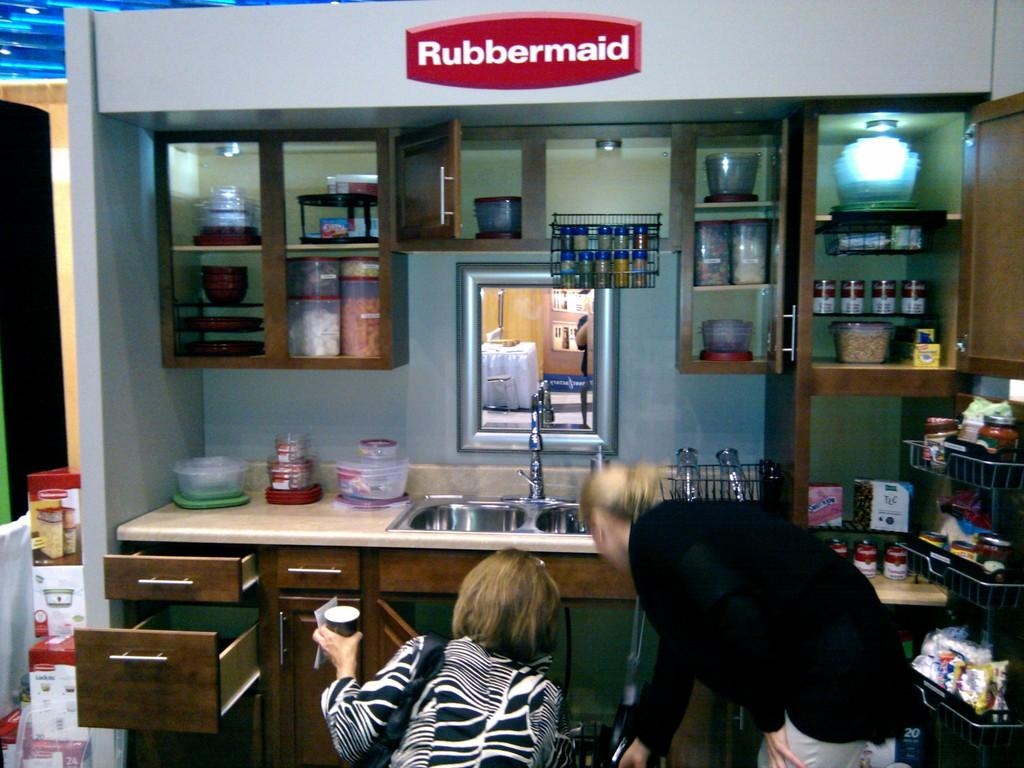<image>
Offer a succinct explanation of the picture presented. A kitchen display is sponsored by the company Rubbermaid. 